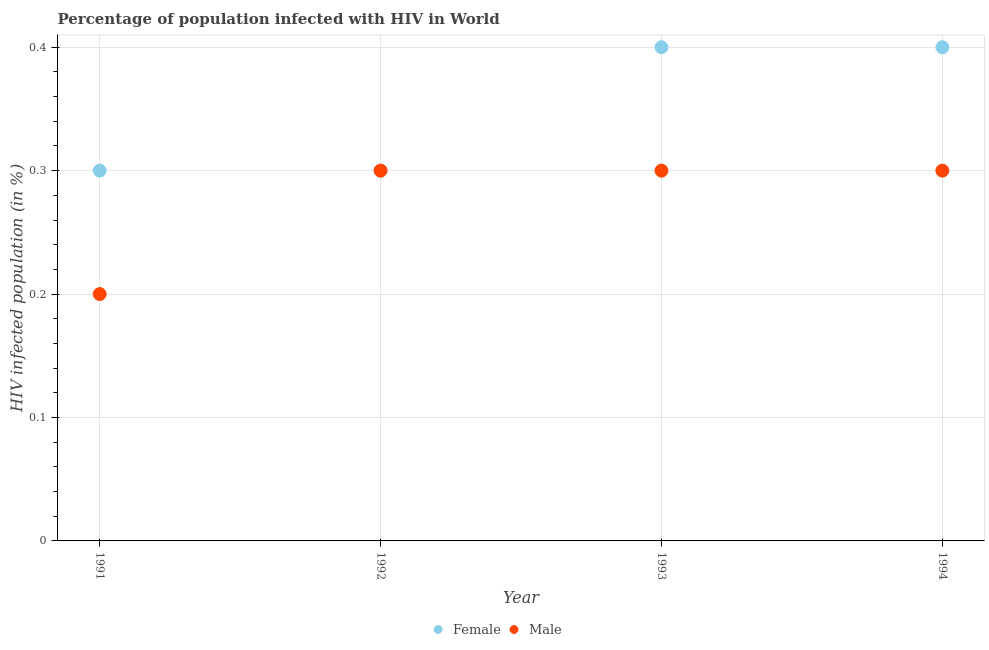What is the percentage of males who are infected with hiv in 1992?
Offer a terse response. 0.3. Across all years, what is the minimum percentage of males who are infected with hiv?
Your answer should be very brief. 0.2. In which year was the percentage of females who are infected with hiv minimum?
Make the answer very short. 1991. What is the difference between the percentage of females who are infected with hiv in 1991 and that in 1993?
Your answer should be compact. -0.1. What is the difference between the percentage of males who are infected with hiv in 1993 and the percentage of females who are infected with hiv in 1991?
Keep it short and to the point. 0. In how many years, is the percentage of males who are infected with hiv greater than 0.30000000000000004 %?
Ensure brevity in your answer.  0. What is the ratio of the percentage of males who are infected with hiv in 1991 to that in 1992?
Give a very brief answer. 0.67. Is the percentage of females who are infected with hiv in 1992 less than that in 1993?
Your response must be concise. Yes. What is the difference between the highest and the second highest percentage of males who are infected with hiv?
Give a very brief answer. 0. What is the difference between the highest and the lowest percentage of males who are infected with hiv?
Give a very brief answer. 0.1. In how many years, is the percentage of males who are infected with hiv greater than the average percentage of males who are infected with hiv taken over all years?
Offer a very short reply. 3. Does the percentage of females who are infected with hiv monotonically increase over the years?
Provide a succinct answer. No. Is the percentage of females who are infected with hiv strictly greater than the percentage of males who are infected with hiv over the years?
Provide a short and direct response. No. How many dotlines are there?
Make the answer very short. 2. How many years are there in the graph?
Provide a succinct answer. 4. What is the difference between two consecutive major ticks on the Y-axis?
Make the answer very short. 0.1. Are the values on the major ticks of Y-axis written in scientific E-notation?
Your answer should be compact. No. Does the graph contain any zero values?
Ensure brevity in your answer.  No. What is the title of the graph?
Your answer should be compact. Percentage of population infected with HIV in World. What is the label or title of the X-axis?
Provide a short and direct response. Year. What is the label or title of the Y-axis?
Provide a short and direct response. HIV infected population (in %). What is the HIV infected population (in %) in Male in 1991?
Offer a very short reply. 0.2. What is the HIV infected population (in %) of Female in 1992?
Offer a terse response. 0.3. What is the HIV infected population (in %) of Female in 1993?
Your answer should be compact. 0.4. What is the HIV infected population (in %) in Female in 1994?
Your answer should be very brief. 0.4. Across all years, what is the maximum HIV infected population (in %) of Female?
Your answer should be compact. 0.4. Across all years, what is the maximum HIV infected population (in %) of Male?
Offer a very short reply. 0.3. Across all years, what is the minimum HIV infected population (in %) of Female?
Make the answer very short. 0.3. What is the total HIV infected population (in %) in Female in the graph?
Your response must be concise. 1.4. What is the total HIV infected population (in %) in Male in the graph?
Offer a very short reply. 1.1. What is the difference between the HIV infected population (in %) of Male in 1991 and that in 1992?
Your answer should be compact. -0.1. What is the difference between the HIV infected population (in %) in Male in 1992 and that in 1993?
Your answer should be compact. 0. What is the difference between the HIV infected population (in %) of Female in 1993 and that in 1994?
Give a very brief answer. 0. What is the difference between the HIV infected population (in %) of Female in 1991 and the HIV infected population (in %) of Male in 1992?
Give a very brief answer. 0. What is the difference between the HIV infected population (in %) of Female in 1991 and the HIV infected population (in %) of Male in 1993?
Ensure brevity in your answer.  0. What is the difference between the HIV infected population (in %) of Female in 1991 and the HIV infected population (in %) of Male in 1994?
Give a very brief answer. 0. What is the difference between the HIV infected population (in %) in Female in 1992 and the HIV infected population (in %) in Male in 1994?
Ensure brevity in your answer.  0. What is the difference between the HIV infected population (in %) in Female in 1993 and the HIV infected population (in %) in Male in 1994?
Your answer should be compact. 0.1. What is the average HIV infected population (in %) in Male per year?
Make the answer very short. 0.28. In the year 1991, what is the difference between the HIV infected population (in %) of Female and HIV infected population (in %) of Male?
Provide a short and direct response. 0.1. In the year 1993, what is the difference between the HIV infected population (in %) in Female and HIV infected population (in %) in Male?
Make the answer very short. 0.1. What is the ratio of the HIV infected population (in %) of Female in 1991 to that in 1992?
Provide a succinct answer. 1. What is the ratio of the HIV infected population (in %) of Male in 1991 to that in 1992?
Make the answer very short. 0.67. What is the ratio of the HIV infected population (in %) of Male in 1991 to that in 1993?
Make the answer very short. 0.67. What is the ratio of the HIV infected population (in %) of Female in 1991 to that in 1994?
Provide a short and direct response. 0.75. What is the ratio of the HIV infected population (in %) of Male in 1992 to that in 1993?
Provide a succinct answer. 1. What is the ratio of the HIV infected population (in %) in Female in 1992 to that in 1994?
Ensure brevity in your answer.  0.75. What is the ratio of the HIV infected population (in %) of Female in 1993 to that in 1994?
Give a very brief answer. 1. What is the difference between the highest and the second highest HIV infected population (in %) of Male?
Offer a terse response. 0. What is the difference between the highest and the lowest HIV infected population (in %) in Female?
Offer a very short reply. 0.1. What is the difference between the highest and the lowest HIV infected population (in %) of Male?
Offer a very short reply. 0.1. 